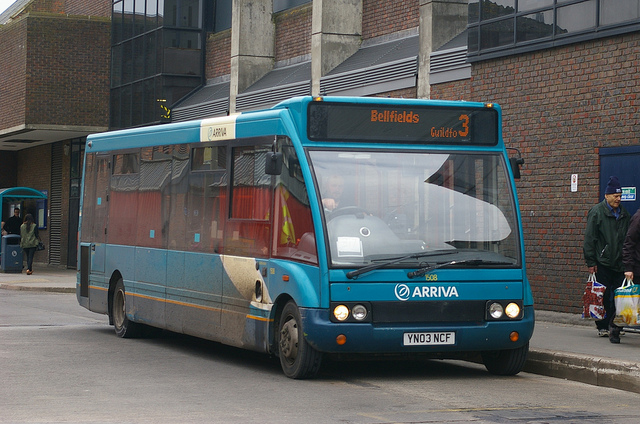Please identify all text content in this image. Bellfields Gunoto 3 ARRIVA NCF YN03 